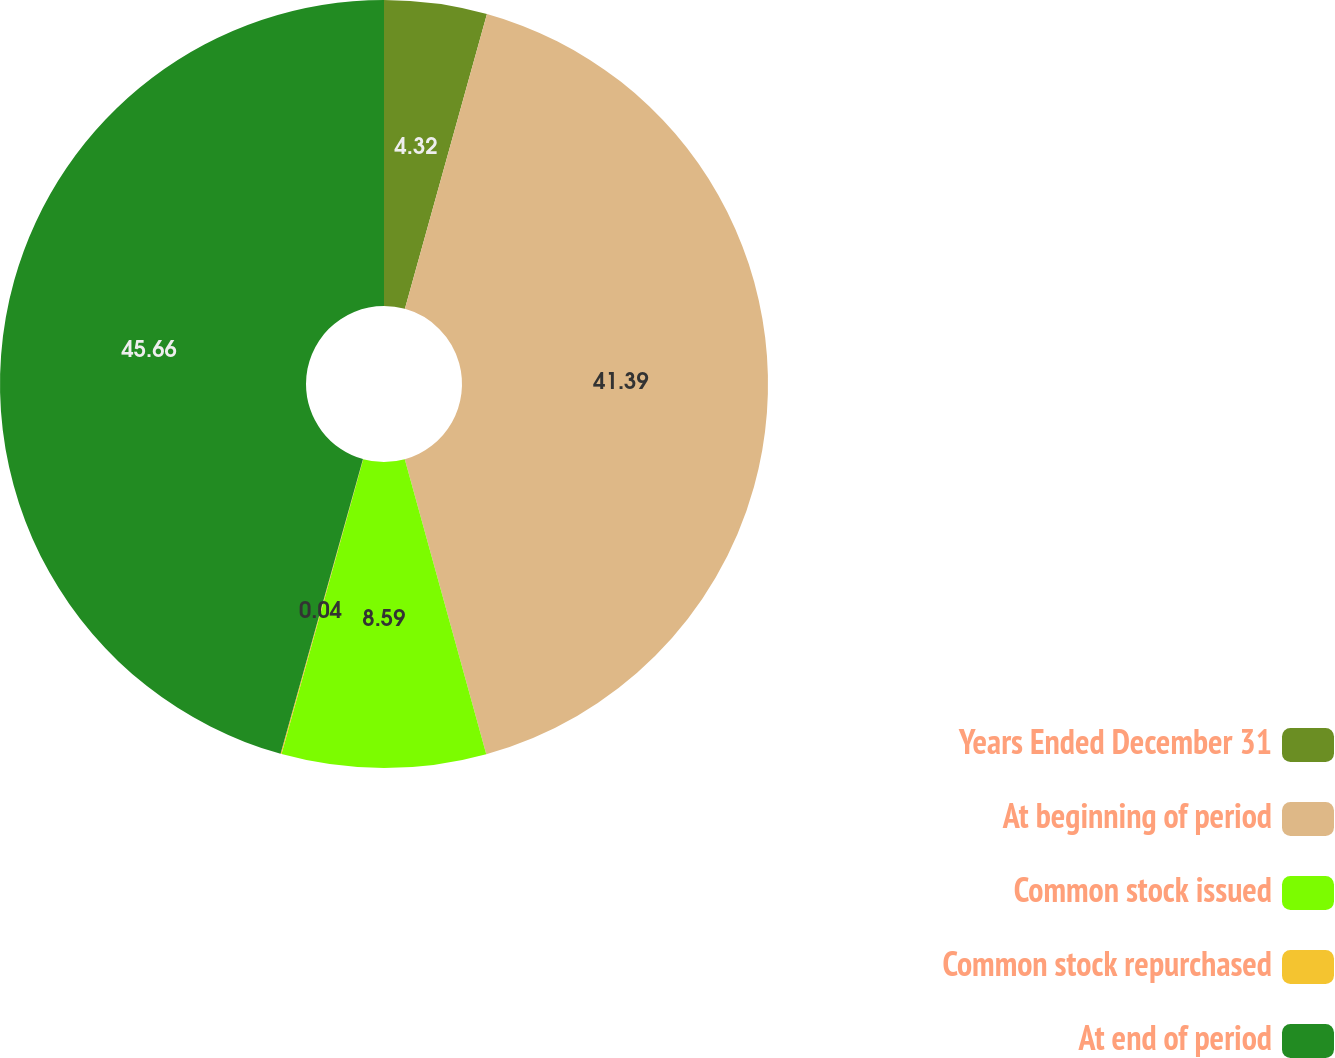<chart> <loc_0><loc_0><loc_500><loc_500><pie_chart><fcel>Years Ended December 31<fcel>At beginning of period<fcel>Common stock issued<fcel>Common stock repurchased<fcel>At end of period<nl><fcel>4.32%<fcel>41.39%<fcel>8.59%<fcel>0.04%<fcel>45.66%<nl></chart> 